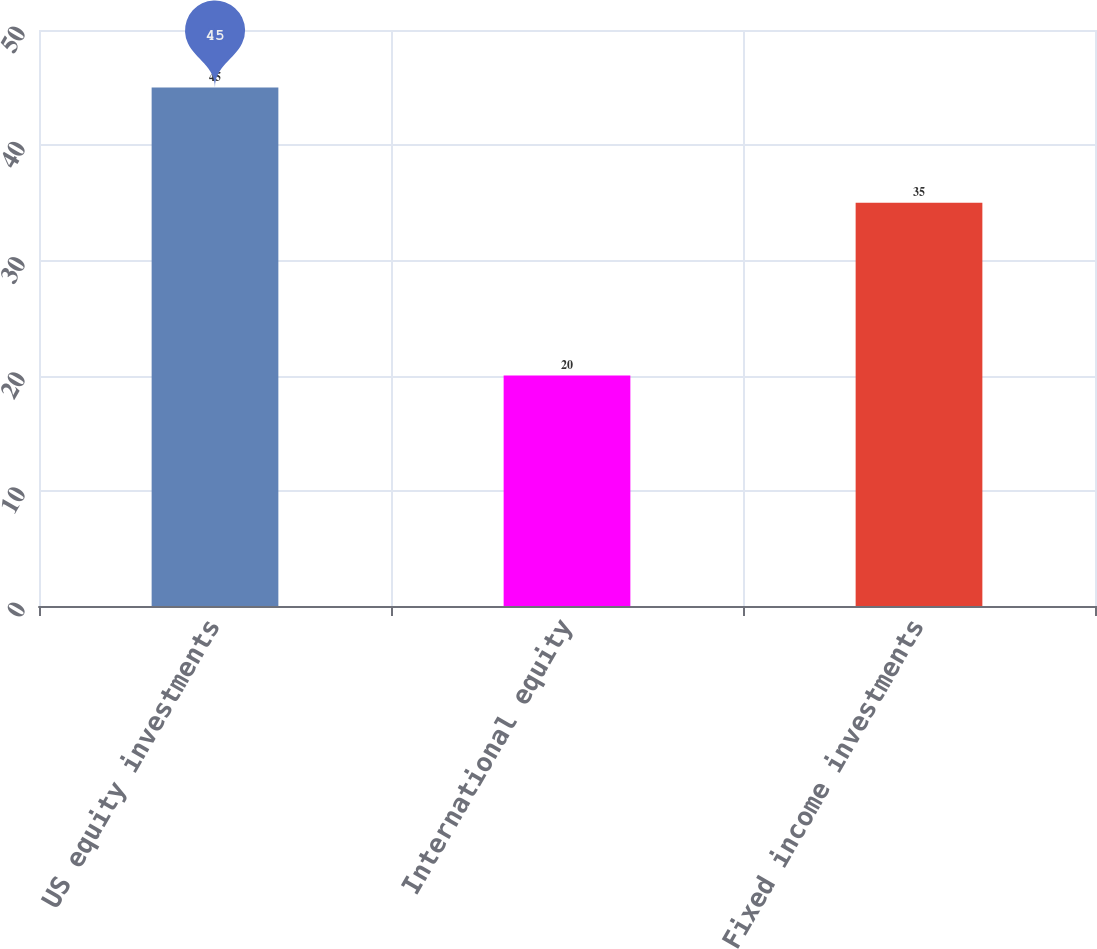<chart> <loc_0><loc_0><loc_500><loc_500><bar_chart><fcel>US equity investments<fcel>International equity<fcel>Fixed income investments<nl><fcel>45<fcel>20<fcel>35<nl></chart> 